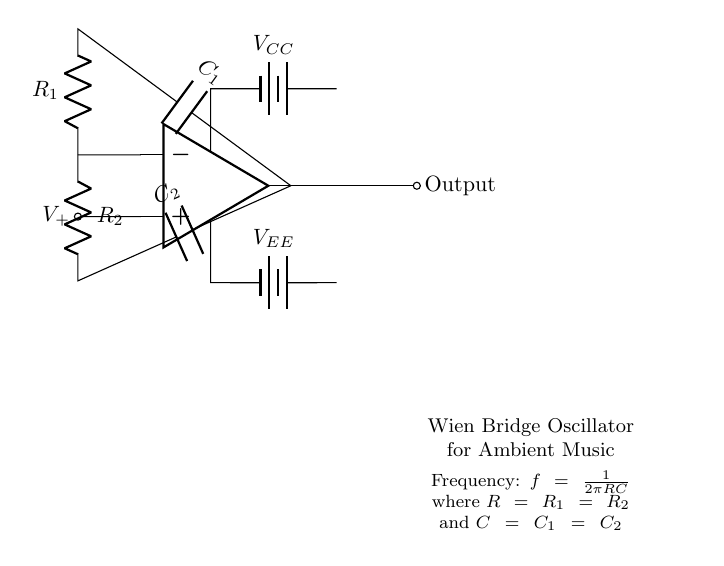What type of oscillator is represented in the circuit? The circuit is a Wien Bridge Oscillator, which is characterized by its use of a bridge circuit configuration to generate sine waves.
Answer: Wien Bridge Oscillator How many resistors are in the circuit? The circuit contains two resistors, labeled as R1 and R2, which are part of the Wien Bridge design to help establish the oscillation condition.
Answer: 2 What is the role of the operational amplifier in this circuit? The operational amplifier amplifies the signal and is essential for the feedback mechanism that sustains the oscillation.
Answer: Amplification What is the frequency formula provided in the diagram? The frequency of the oscillator is given by the formula f = 1/(2πRC), indicating it is dependent on the resistances R and capacitances C used in the circuit.
Answer: f = 1/(2πRC) What are the values of the power supply voltages indicated in the circuit? The circuit shows the voltage supplies labeled as VCC for the positive rail and VEE for the negative rail, which provide the necessary power for the op-amp operation.
Answer: VCC and VEE Which components in the circuit are responsible for setting the oscillation frequency? The frequency is set by the values of the resistors R1, R2, and the capacitors C1, C2. The description states that R should be equal in the two branches and C should be equal in the two branches for the oscillation to occur.
Answer: R1, R2, C1, C2 